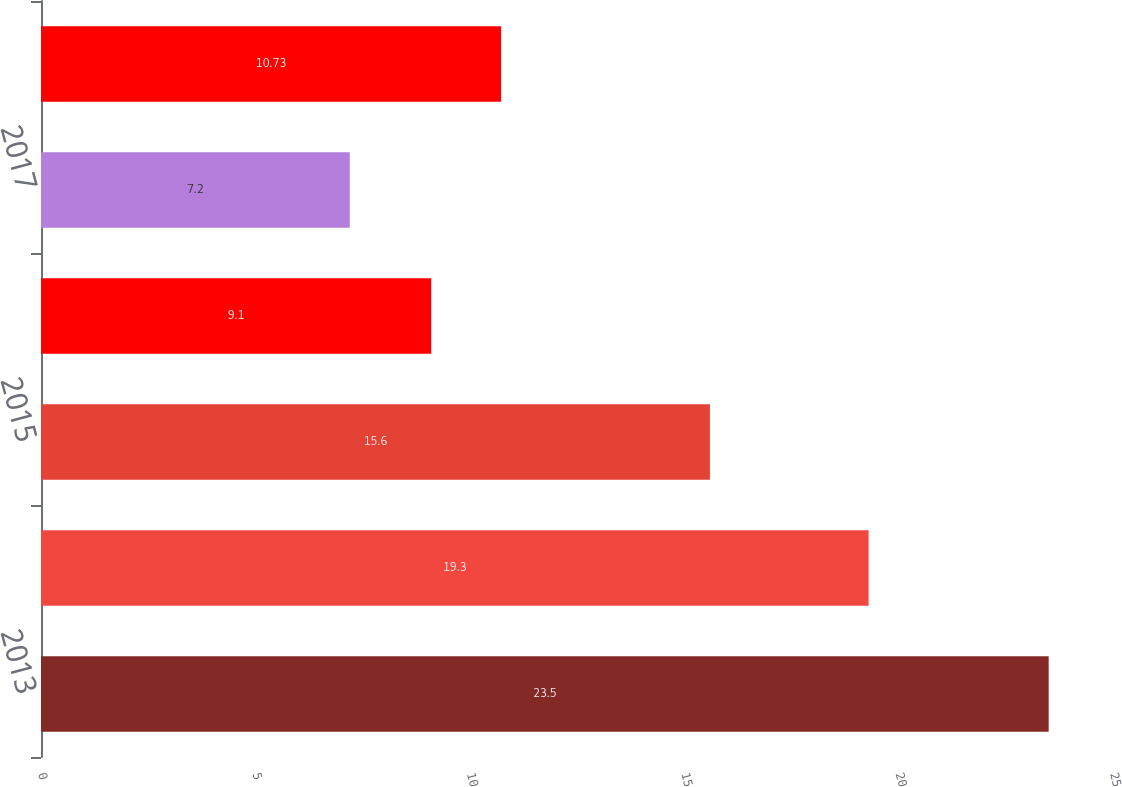Convert chart. <chart><loc_0><loc_0><loc_500><loc_500><bar_chart><fcel>2013<fcel>2014<fcel>2015<fcel>2016<fcel>2017<fcel>Thereafter<nl><fcel>23.5<fcel>19.3<fcel>15.6<fcel>9.1<fcel>7.2<fcel>10.73<nl></chart> 